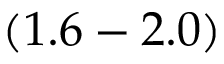<formula> <loc_0><loc_0><loc_500><loc_500>( 1 . 6 - 2 . 0 )</formula> 